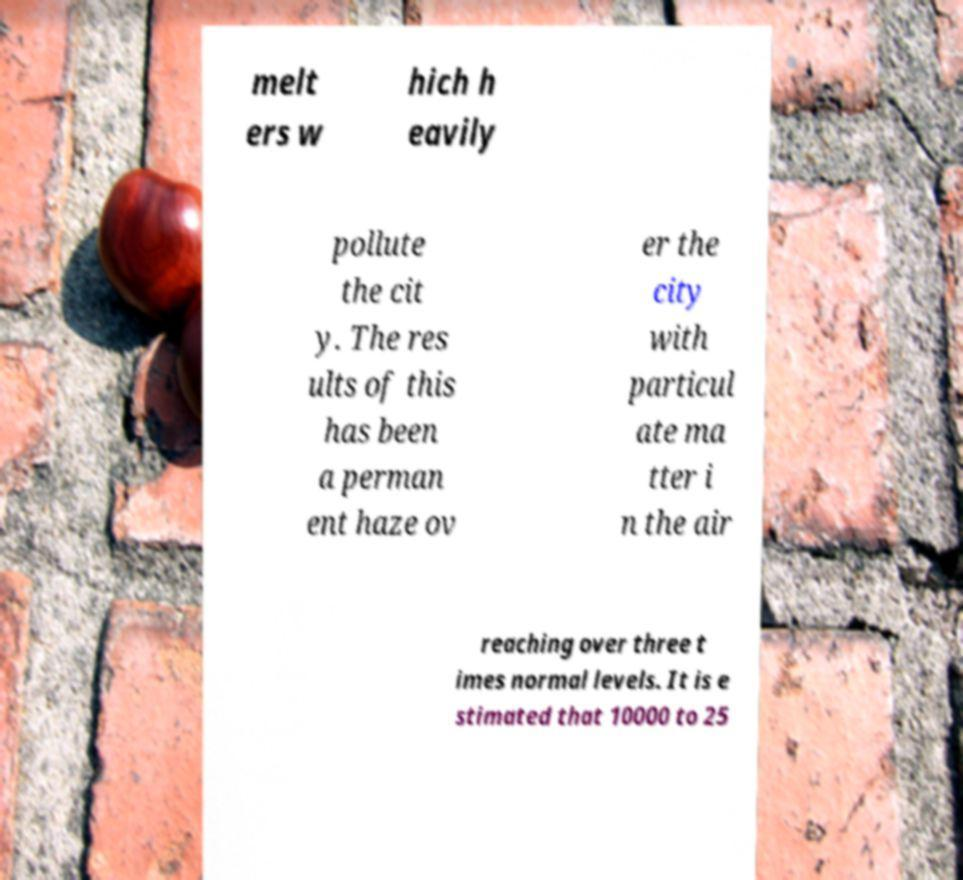Could you assist in decoding the text presented in this image and type it out clearly? melt ers w hich h eavily pollute the cit y. The res ults of this has been a perman ent haze ov er the city with particul ate ma tter i n the air reaching over three t imes normal levels. It is e stimated that 10000 to 25 